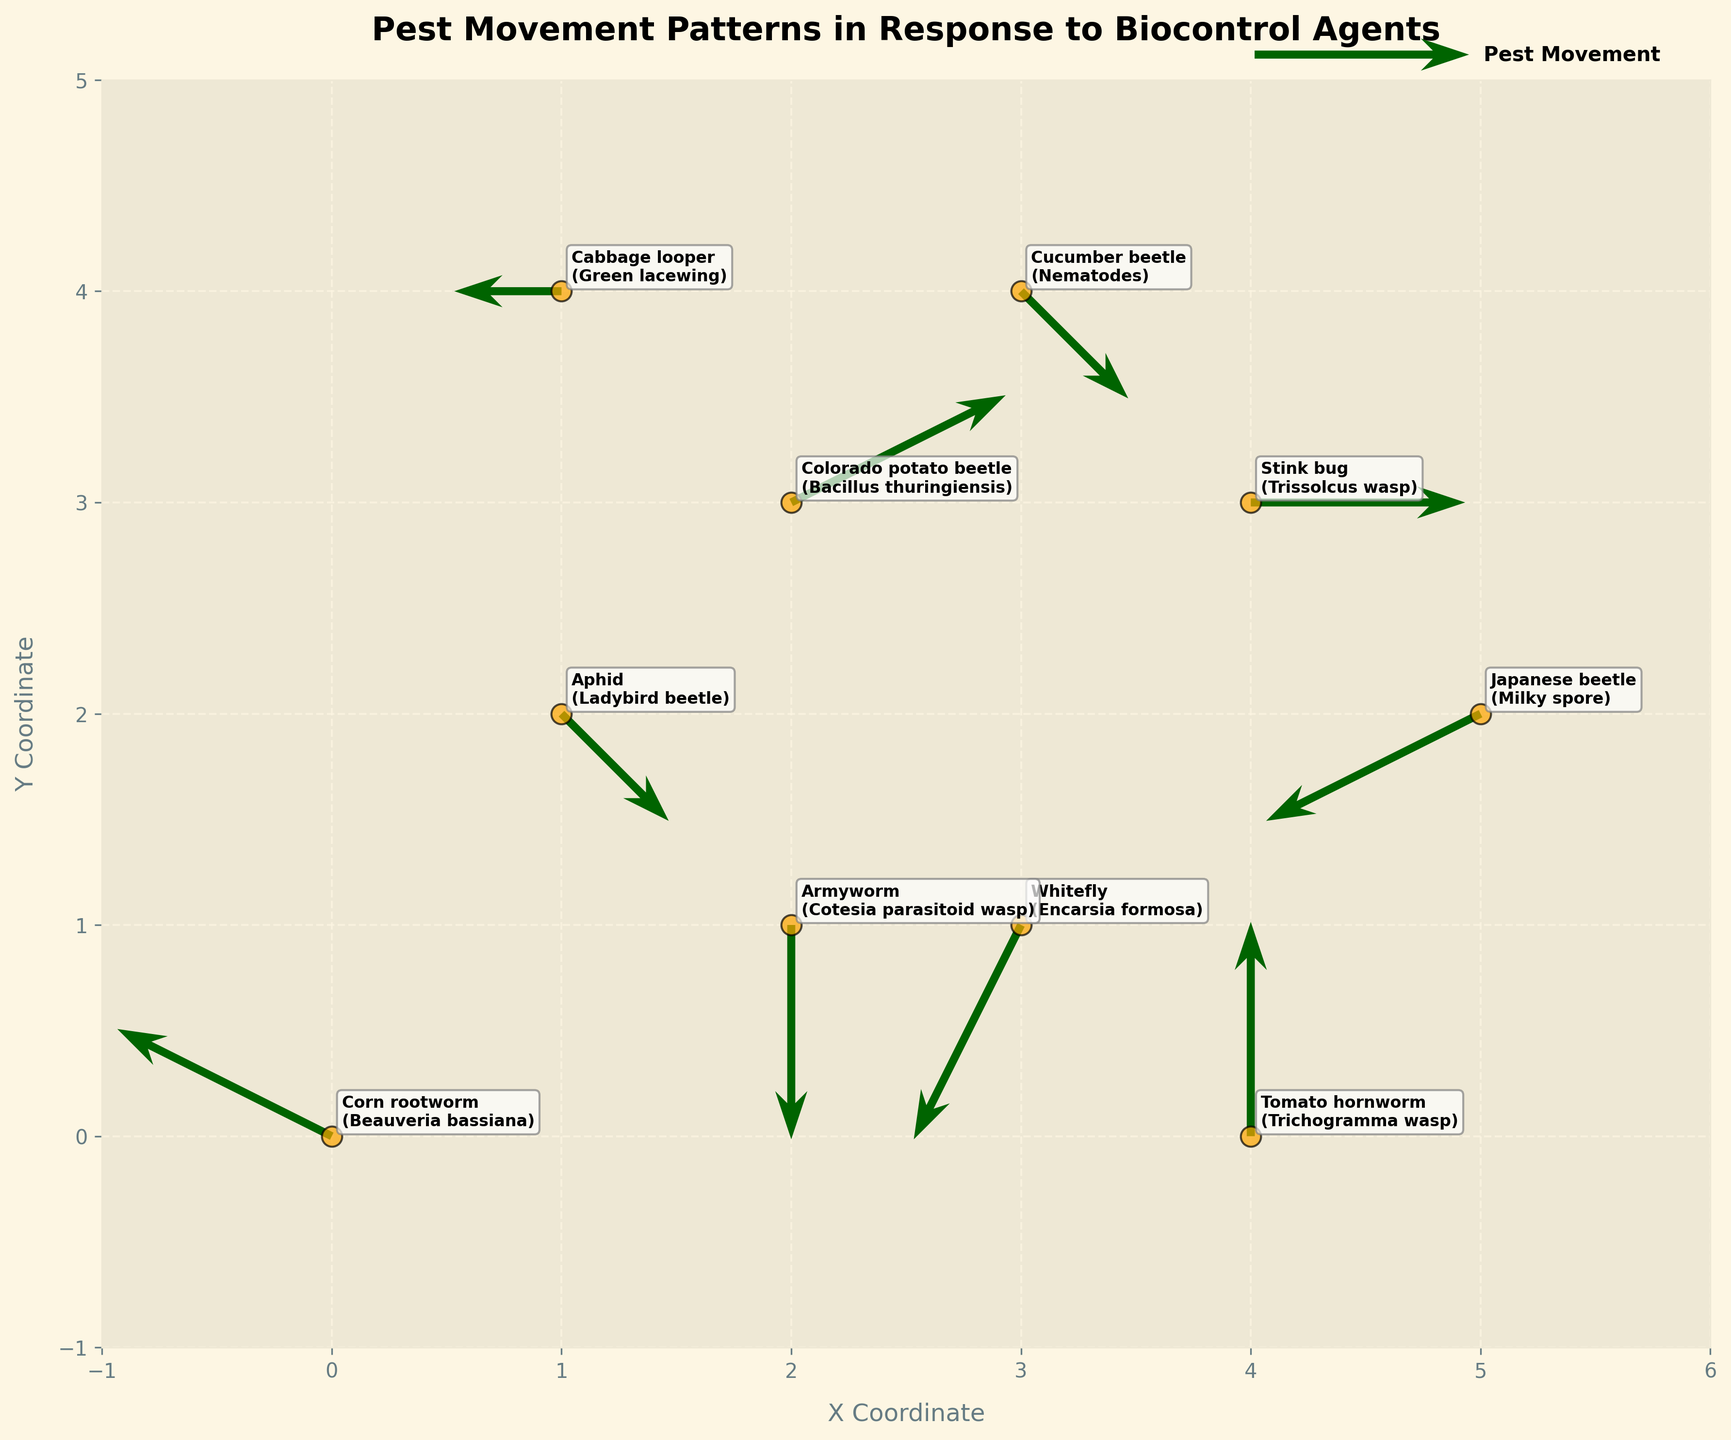How many pest movements (arrows) are shown in the figure? There are 10 rows in the provided data, each representing a pest movement with coordinates and direction. Therefore, there are 10 arrows in the figure.
Answer: 10 What are the colors used for the arrows and the pest locations? The arrows are colored dark green, and the pest locations are marked with orange circles.
Answer: Dark green and orange What is the title of the figure? The title of the figure is displayed at the top and reads "Pest Movement Patterns in Response to Biocontrol Agents".
Answer: Pest Movement Patterns in Response to Biocontrol Agents Which pest has the largest horizontal movement component? By comparing the x-components (u values) of the movements, the Colorado potato beetle has the largest horizontal movement of 2.
Answer: Colorado potato beetle Which pest moved vertically upwards, and what biocontrol agent was used there? The tomato hornworm moved vertically upwards with a v component of 2, and the biocontrol agent used was Trichogramma wasp.
Answer: Tomato hornworm; Trichogramma wasp What is the combined movement vector (u+v) for the Armyworm? The vector components for the Armyworm are (0, -2). Adding these components results in a combined movement vector of 0 + (-2) = -2.
Answer: -2 What are the coordinates and direction of movement for the Japanese beetle? The Japanese beetle is located at (5, 2) and moves leftward and downward with components (-2, -1).
Answer: (5, 2); (-2, -1) Which pest's movement results in a net upward displacement? The Colorado potato beetle's (2, 1) and the tomato hornworm’s (0, 2) movements both result in net upward displacement where v > 0.
Answer: Colorado potato beetle, tomato hornworm How does the direction of movement differ between the Cabbage looper and the Cucumber beetle? The Cabbage looper moves left with no vertical displacement (-1, 0), while the Cucumber beetle moves rightward and slightly downward (1, -1).
Answer: Cabbage looper moves left, Cucumber beetle moves right and down Which biocontrol agent is associated with the pest that has an upward and leftward movement? The Corn rootworm moves upward and leftward with vector components (-2, 1) and is associated with Beauveria bassiana.
Answer: Beauveria bassiana 